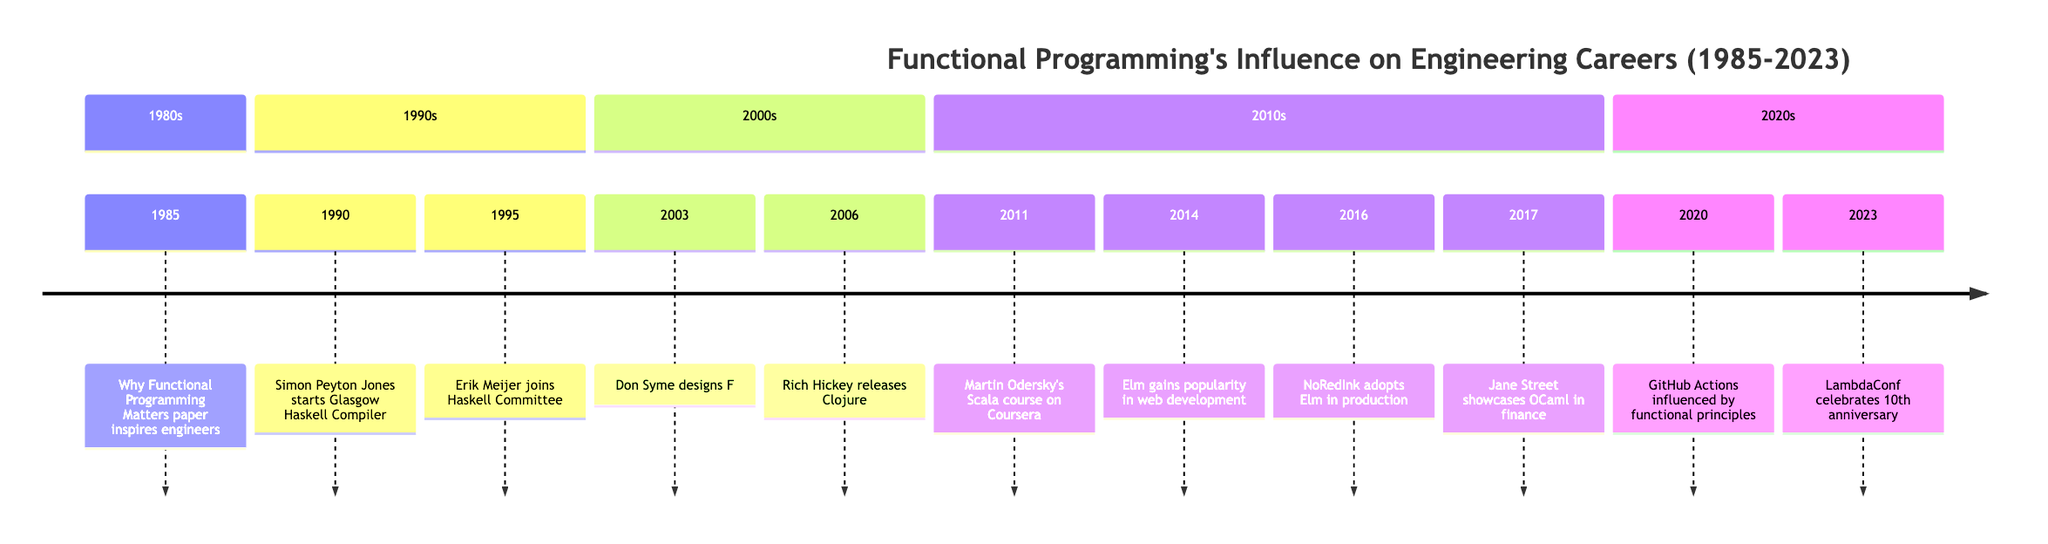What year was 'Why Functional Programming Matters' published? The timeline indicates that the event occurred in 1985, which is the year associated with the publication of the significant paper.
Answer: 1985 Which engineer began working on the Glasgow Haskell Compiler? The timeline clearly states that Simon Peyton Jones started working on the Glasgow Haskell Compiler in 1990.
Answer: Simon Peyton Jones In what year did Elm gain popularity in web development? According to the timeline, Elm gained popularity in web development in the year 2014, as explicitly noted.
Answer: 2014 How many major events related to functional programming occurred in the 2000s? By reviewing the timeline, we can count that there are three major events listed in the 2000s: 2003 (F# design), and 2006 (Clojure release).
Answer: 3 What influence did Martin Odersky's course have on functional programming? The timeline conveys that Martin Odersky's course in 2011 brought global attention to Scala, leading it to become a popular choice for functional programming in the industry.
Answer: Popularity of Scala What significant trend did GitHub Actions demonstrate in 2020? The timeline specifies that GitHub Actions was heavily influenced by functional programming principles, showcasing the operational efficiencies it brought to DevOps practices.
Answer: Operational efficiencies in DevOps Who designed the F# language? The timeline indicates that the F# language was designed by Don Syme at Microsoft in 2003.
Answer: Don Syme What notable adoption occurred for Elm in 2016? The timeline shows that in 2016, NoRedInk adopted Elm in production, highlighting its corporate application.
Answer: NoRedInk Which language was prominently used at Jane Street in 2017? The timeline notes that Jane Street reported extensive use of the OCaml language in the context of systems trading, indicating the language's specific application.
Answer: OCaml 